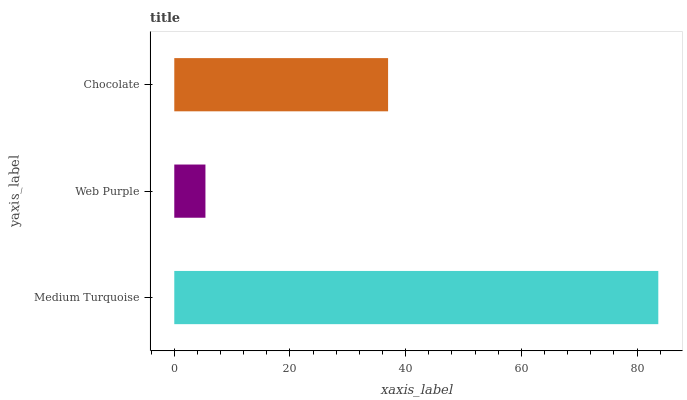Is Web Purple the minimum?
Answer yes or no. Yes. Is Medium Turquoise the maximum?
Answer yes or no. Yes. Is Chocolate the minimum?
Answer yes or no. No. Is Chocolate the maximum?
Answer yes or no. No. Is Chocolate greater than Web Purple?
Answer yes or no. Yes. Is Web Purple less than Chocolate?
Answer yes or no. Yes. Is Web Purple greater than Chocolate?
Answer yes or no. No. Is Chocolate less than Web Purple?
Answer yes or no. No. Is Chocolate the high median?
Answer yes or no. Yes. Is Chocolate the low median?
Answer yes or no. Yes. Is Web Purple the high median?
Answer yes or no. No. Is Medium Turquoise the low median?
Answer yes or no. No. 